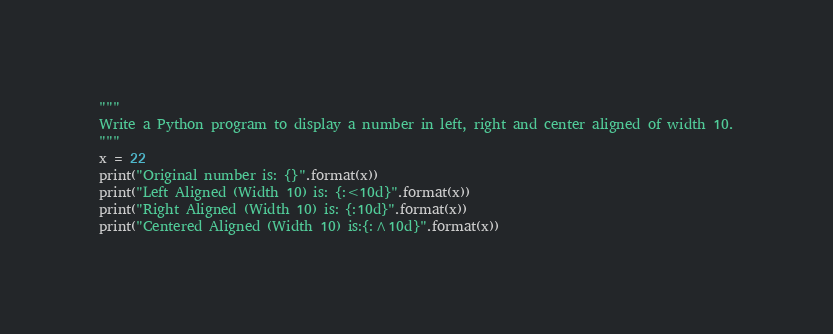<code> <loc_0><loc_0><loc_500><loc_500><_Python_>"""
Write a Python program to display a number in left, right and center aligned of width 10.
"""
x = 22
print("Original number is: {}".format(x))
print("Left Aligned (Width 10) is: {:<10d}".format(x))
print("Right Aligned (Width 10) is: {:10d}".format(x))
print("Centered Aligned (Width 10) is:{:^10d}".format(x))</code> 